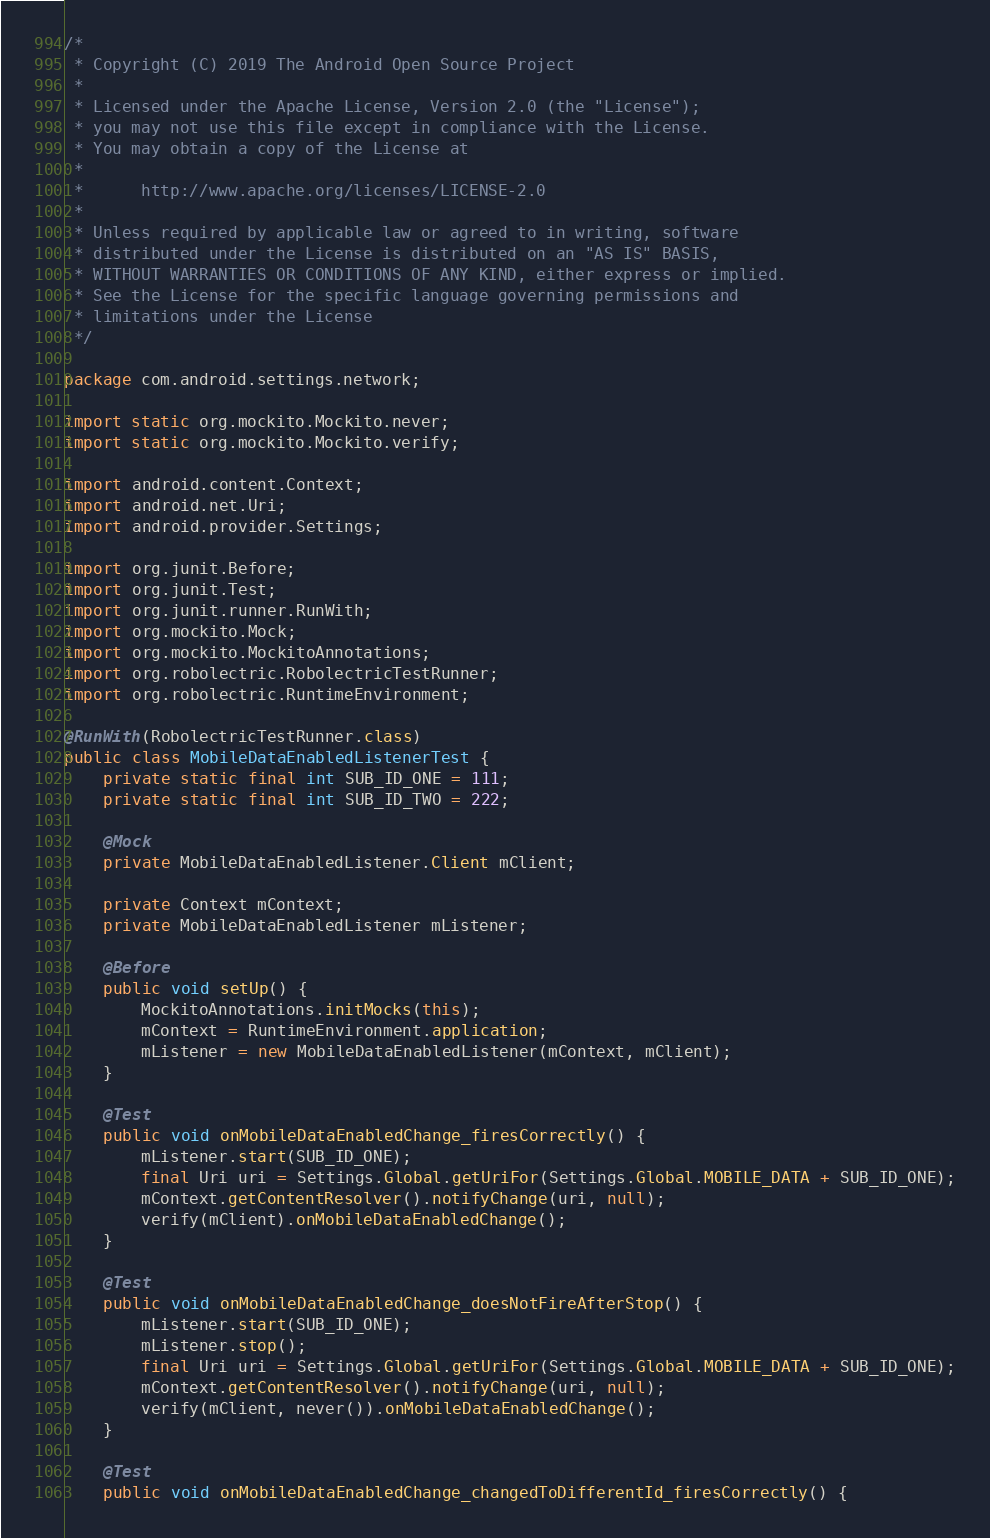<code> <loc_0><loc_0><loc_500><loc_500><_Java_>/*
 * Copyright (C) 2019 The Android Open Source Project
 *
 * Licensed under the Apache License, Version 2.0 (the "License");
 * you may not use this file except in compliance with the License.
 * You may obtain a copy of the License at
 *
 *      http://www.apache.org/licenses/LICENSE-2.0
 *
 * Unless required by applicable law or agreed to in writing, software
 * distributed under the License is distributed on an "AS IS" BASIS,
 * WITHOUT WARRANTIES OR CONDITIONS OF ANY KIND, either express or implied.
 * See the License for the specific language governing permissions and
 * limitations under the License
 */

package com.android.settings.network;

import static org.mockito.Mockito.never;
import static org.mockito.Mockito.verify;

import android.content.Context;
import android.net.Uri;
import android.provider.Settings;

import org.junit.Before;
import org.junit.Test;
import org.junit.runner.RunWith;
import org.mockito.Mock;
import org.mockito.MockitoAnnotations;
import org.robolectric.RobolectricTestRunner;
import org.robolectric.RuntimeEnvironment;

@RunWith(RobolectricTestRunner.class)
public class MobileDataEnabledListenerTest {
    private static final int SUB_ID_ONE = 111;
    private static final int SUB_ID_TWO = 222;

    @Mock
    private MobileDataEnabledListener.Client mClient;

    private Context mContext;
    private MobileDataEnabledListener mListener;

    @Before
    public void setUp() {
        MockitoAnnotations.initMocks(this);
        mContext = RuntimeEnvironment.application;
        mListener = new MobileDataEnabledListener(mContext, mClient);
    }

    @Test
    public void onMobileDataEnabledChange_firesCorrectly() {
        mListener.start(SUB_ID_ONE);
        final Uri uri = Settings.Global.getUriFor(Settings.Global.MOBILE_DATA + SUB_ID_ONE);
        mContext.getContentResolver().notifyChange(uri, null);
        verify(mClient).onMobileDataEnabledChange();
    }

    @Test
    public void onMobileDataEnabledChange_doesNotFireAfterStop() {
        mListener.start(SUB_ID_ONE);
        mListener.stop();
        final Uri uri = Settings.Global.getUriFor(Settings.Global.MOBILE_DATA + SUB_ID_ONE);
        mContext.getContentResolver().notifyChange(uri, null);
        verify(mClient, never()).onMobileDataEnabledChange();
    }

    @Test
    public void onMobileDataEnabledChange_changedToDifferentId_firesCorrectly() {</code> 